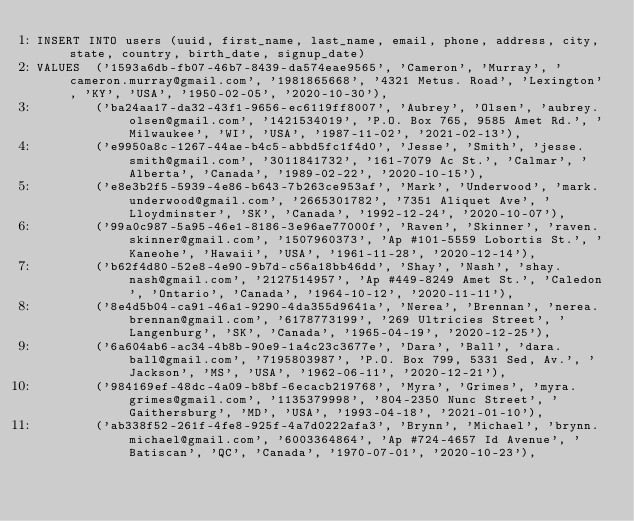Convert code to text. <code><loc_0><loc_0><loc_500><loc_500><_SQL_>INSERT INTO users (uuid, first_name, last_name, email, phone, address, city, state, country, birth_date, signup_date)
VALUES  ('1593a6db-fb07-46b7-8439-da574eae9565', 'Cameron', 'Murray', 'cameron.murray@gmail.com', '1981865668', '4321 Metus. Road', 'Lexington', 'KY', 'USA', '1950-02-05', '2020-10-30'),
        ('ba24aa17-da32-43f1-9656-ec6119ff8007', 'Aubrey', 'Olsen', 'aubrey.olsen@gmail.com', '1421534019', 'P.O. Box 765, 9585 Amet Rd.', 'Milwaukee', 'WI', 'USA', '1987-11-02', '2021-02-13'),
        ('e9950a8c-1267-44ae-b4c5-abbd5fc1f4d0', 'Jesse', 'Smith', 'jesse.smith@gmail.com', '3011841732', '161-7079 Ac St.', 'Calmar', 'Alberta', 'Canada', '1989-02-22', '2020-10-15'),
        ('e8e3b2f5-5939-4e86-b643-7b263ce953af', 'Mark', 'Underwood', 'mark.underwood@gmail.com', '2665301782', '7351 Aliquet Ave', 'Lloydminster', 'SK', 'Canada', '1992-12-24', '2020-10-07'),
        ('99a0c987-5a95-46e1-8186-3e96ae77000f', 'Raven', 'Skinner', 'raven.skinner@gmail.com', '1507960373', 'Ap #101-5559 Lobortis St.', 'Kaneohe', 'Hawaii', 'USA', '1961-11-28', '2020-12-14'),
        ('b62f4d80-52e8-4e90-9b7d-c56a18bb46dd', 'Shay', 'Nash', 'shay.nash@gmail.com', '2127514957', 'Ap #449-8249 Amet St.', 'Caledon', 'Ontario', 'Canada', '1964-10-12', '2020-11-11'),
        ('8e4d5b04-ca91-46a1-9290-4da355d9641a', 'Nerea', 'Brennan', 'nerea.brennan@gmail.com', '6178773199', '269 Ultricies Street', 'Langenburg', 'SK', 'Canada', '1965-04-19', '2020-12-25'),
        ('6a604ab6-ac34-4b8b-90e9-1a4c23c3677e', 'Dara', 'Ball', 'dara.ball@gmail.com', '7195803987', 'P.O. Box 799, 5331 Sed, Av.', 'Jackson', 'MS', 'USA', '1962-06-11', '2020-12-21'),
        ('984169ef-48dc-4a09-b8bf-6ecacb219768', 'Myra', 'Grimes', 'myra.grimes@gmail.com', '1135379998', '804-2350 Nunc Street', 'Gaithersburg', 'MD', 'USA', '1993-04-18', '2021-01-10'),
        ('ab338f52-261f-4fe8-925f-4a7d0222afa3', 'Brynn', 'Michael', 'brynn.michael@gmail.com', '6003364864', 'Ap #724-4657 Id Avenue', 'Batiscan', 'QC', 'Canada', '1970-07-01', '2020-10-23'),</code> 